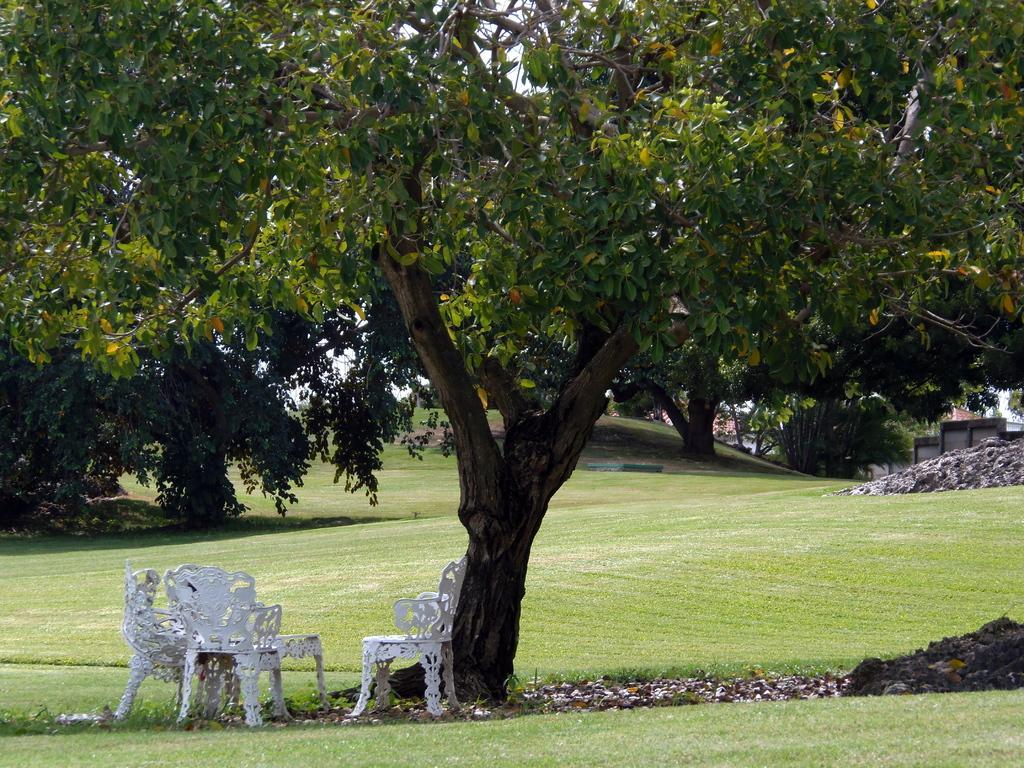How would you summarize this image in a sentence or two? In this image, we can see some trees, houses, chairs. We can see the ground with some objects. We can also see some grass and the sky. We can see a table. 